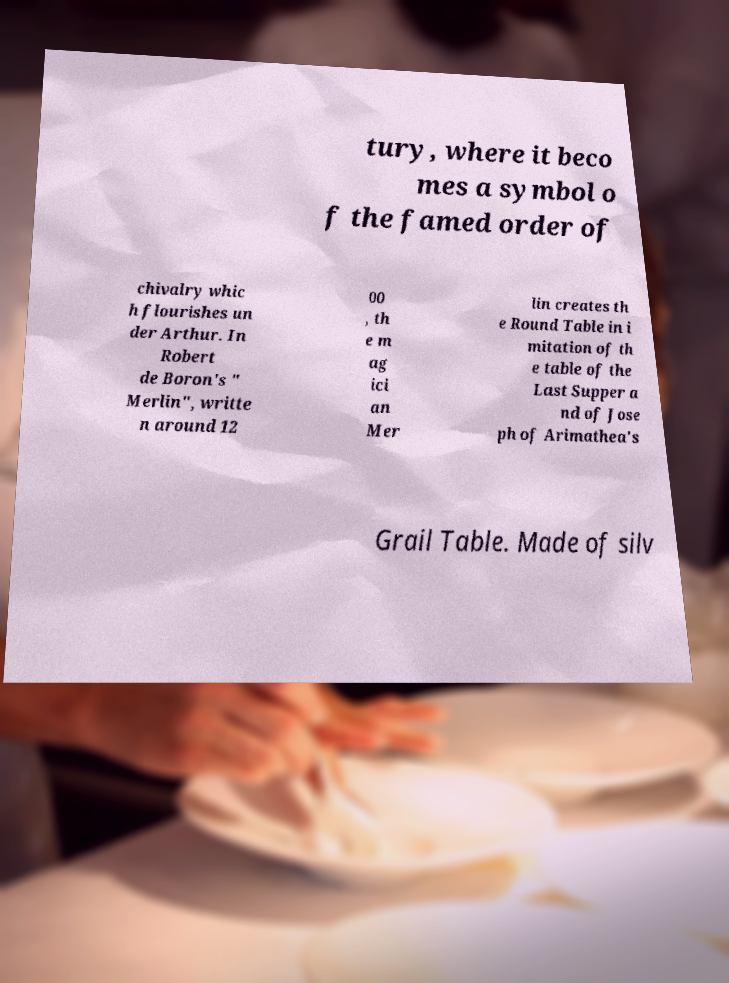Please read and relay the text visible in this image. What does it say? tury, where it beco mes a symbol o f the famed order of chivalry whic h flourishes un der Arthur. In Robert de Boron's " Merlin", writte n around 12 00 , th e m ag ici an Mer lin creates th e Round Table in i mitation of th e table of the Last Supper a nd of Jose ph of Arimathea's Grail Table. Made of silv 